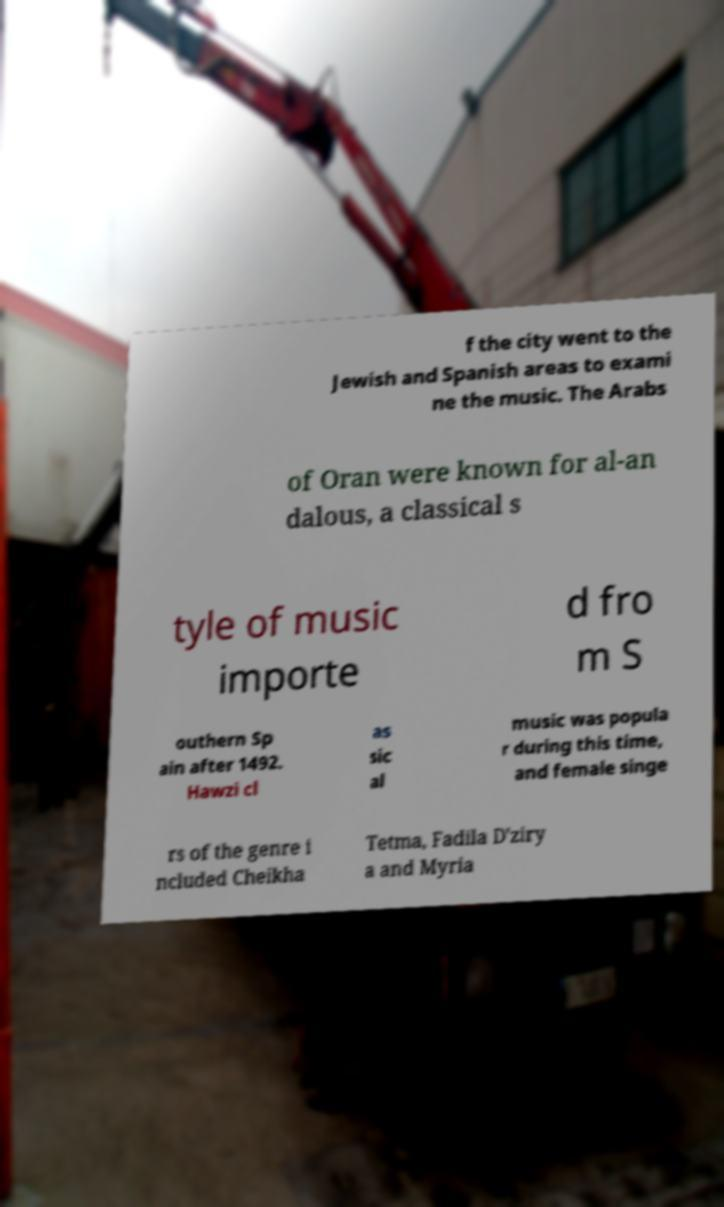There's text embedded in this image that I need extracted. Can you transcribe it verbatim? f the city went to the Jewish and Spanish areas to exami ne the music. The Arabs of Oran were known for al-an dalous, a classical s tyle of music importe d fro m S outhern Sp ain after 1492. Hawzi cl as sic al music was popula r during this time, and female singe rs of the genre i ncluded Cheikha Tetma, Fadila D'ziry a and Myria 